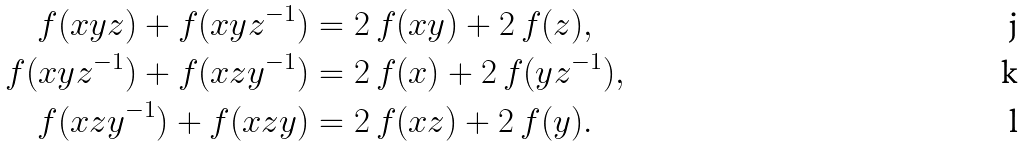Convert formula to latex. <formula><loc_0><loc_0><loc_500><loc_500>f ( x y z ) + f ( x y z ^ { - 1 } ) & = 2 \, f ( x y ) + 2 \, f ( z ) , \\ f ( x y z ^ { - 1 } ) + f ( x z y ^ { - 1 } ) & = 2 \, f ( x ) + 2 \, f ( y z ^ { - 1 } ) , \\ f ( x z y ^ { - 1 } ) + f ( x z y ) & = 2 \, f ( x z ) + 2 \, f ( y ) .</formula> 